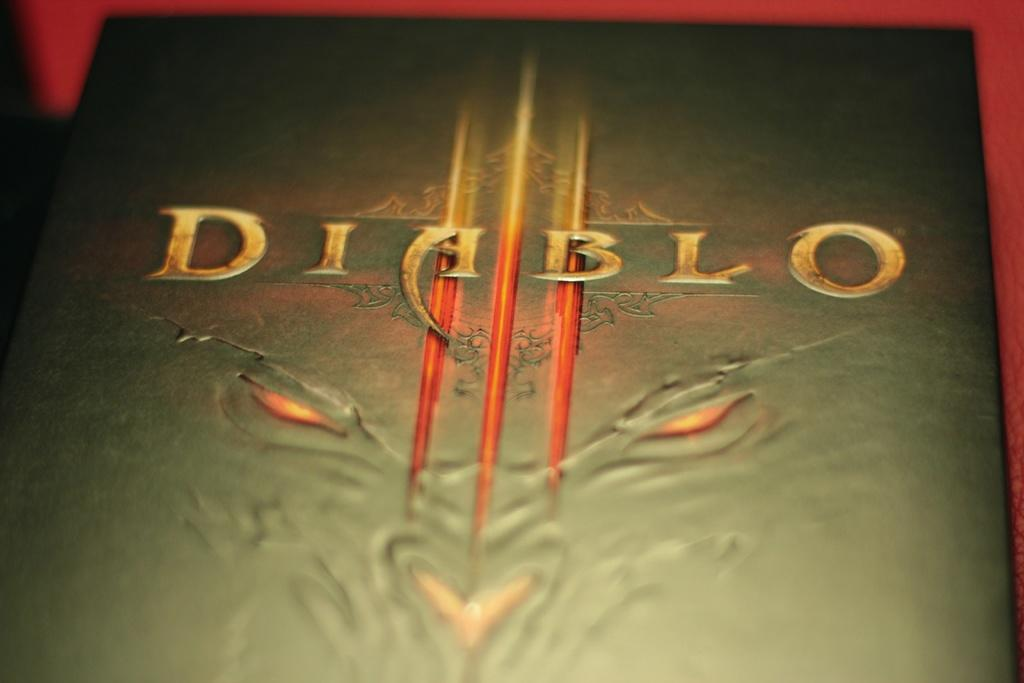What object can be seen in the image? There is a book in the image. What is the color of the book? The book is black in color. What color is the background of the image? The background of the image is red. Is there a kite flying in the image? No, there is no kite present in the image. Can you see any magic happening in the image? No, there is no magic happening in the image. 